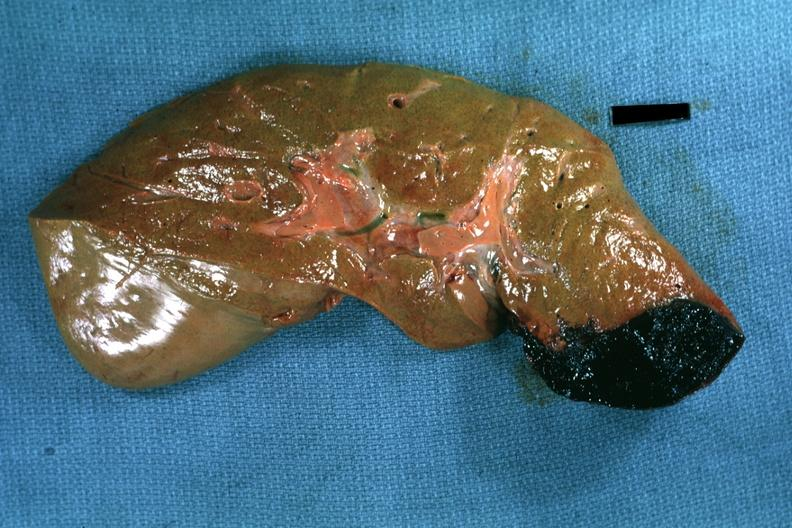what is present?
Answer the question using a single word or phrase. Hepatobiliary 